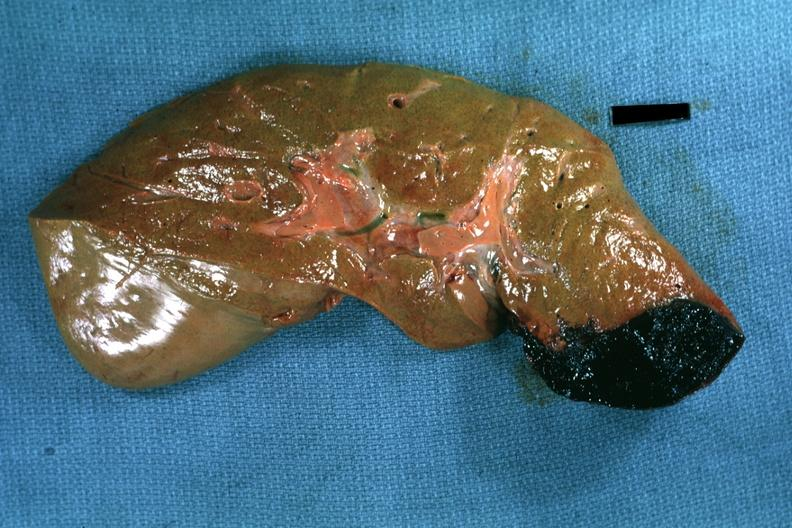what is present?
Answer the question using a single word or phrase. Hepatobiliary 